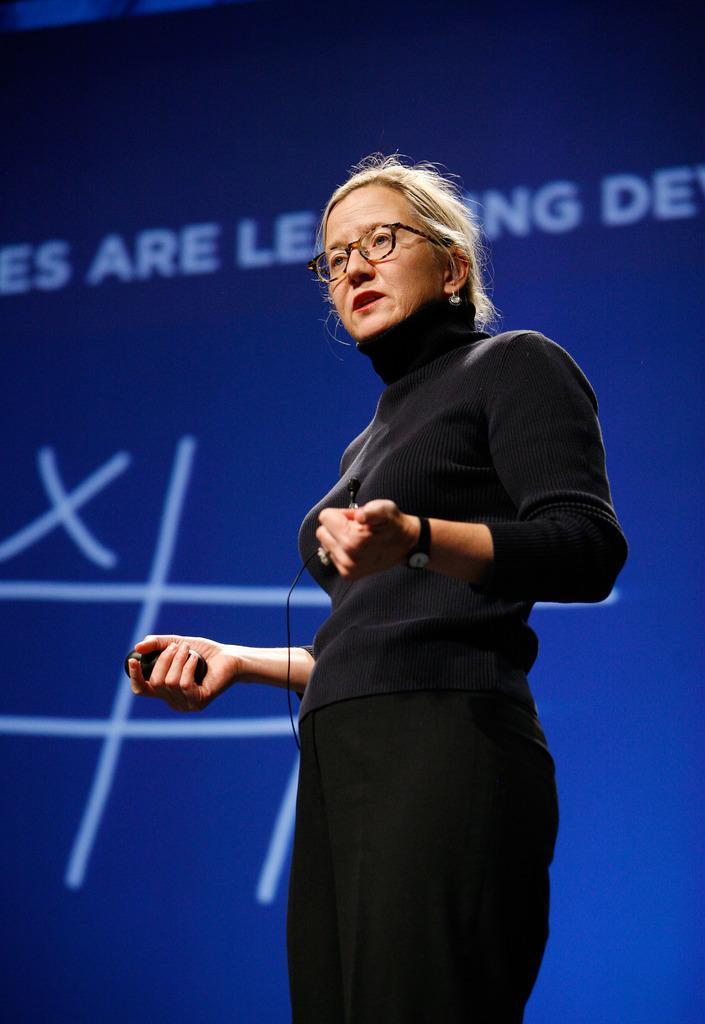Please provide a concise description of this image. In this picture we can see an old woman wearing black dress and standing on the stage. Behind there is a blue banner. 